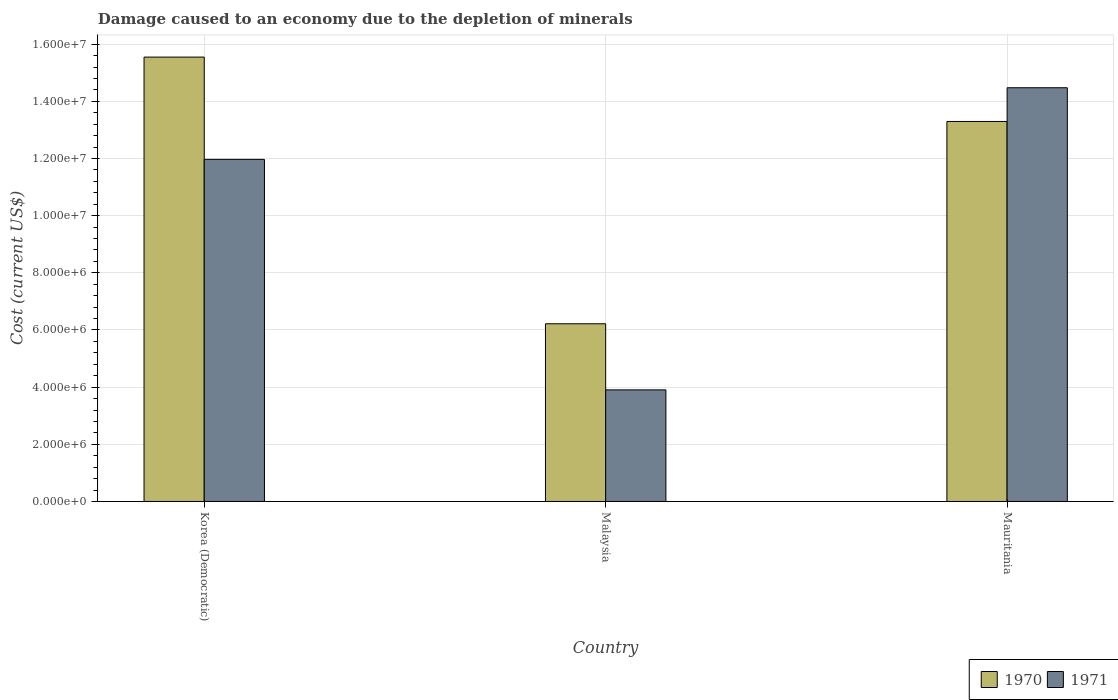How many different coloured bars are there?
Provide a succinct answer. 2. Are the number of bars per tick equal to the number of legend labels?
Provide a succinct answer. Yes. How many bars are there on the 3rd tick from the right?
Keep it short and to the point. 2. What is the label of the 3rd group of bars from the left?
Ensure brevity in your answer.  Mauritania. In how many cases, is the number of bars for a given country not equal to the number of legend labels?
Provide a succinct answer. 0. What is the cost of damage caused due to the depletion of minerals in 1971 in Malaysia?
Offer a very short reply. 3.90e+06. Across all countries, what is the maximum cost of damage caused due to the depletion of minerals in 1970?
Give a very brief answer. 1.55e+07. Across all countries, what is the minimum cost of damage caused due to the depletion of minerals in 1970?
Give a very brief answer. 6.22e+06. In which country was the cost of damage caused due to the depletion of minerals in 1970 maximum?
Ensure brevity in your answer.  Korea (Democratic). In which country was the cost of damage caused due to the depletion of minerals in 1970 minimum?
Give a very brief answer. Malaysia. What is the total cost of damage caused due to the depletion of minerals in 1970 in the graph?
Provide a succinct answer. 3.51e+07. What is the difference between the cost of damage caused due to the depletion of minerals in 1970 in Malaysia and that in Mauritania?
Offer a terse response. -7.08e+06. What is the difference between the cost of damage caused due to the depletion of minerals in 1970 in Mauritania and the cost of damage caused due to the depletion of minerals in 1971 in Malaysia?
Offer a very short reply. 9.39e+06. What is the average cost of damage caused due to the depletion of minerals in 1970 per country?
Keep it short and to the point. 1.17e+07. What is the difference between the cost of damage caused due to the depletion of minerals of/in 1970 and cost of damage caused due to the depletion of minerals of/in 1971 in Malaysia?
Offer a terse response. 2.31e+06. In how many countries, is the cost of damage caused due to the depletion of minerals in 1971 greater than 14800000 US$?
Ensure brevity in your answer.  0. What is the ratio of the cost of damage caused due to the depletion of minerals in 1970 in Korea (Democratic) to that in Malaysia?
Your answer should be very brief. 2.5. Is the cost of damage caused due to the depletion of minerals in 1971 in Korea (Democratic) less than that in Malaysia?
Make the answer very short. No. Is the difference between the cost of damage caused due to the depletion of minerals in 1970 in Korea (Democratic) and Malaysia greater than the difference between the cost of damage caused due to the depletion of minerals in 1971 in Korea (Democratic) and Malaysia?
Your response must be concise. Yes. What is the difference between the highest and the second highest cost of damage caused due to the depletion of minerals in 1970?
Provide a succinct answer. 7.08e+06. What is the difference between the highest and the lowest cost of damage caused due to the depletion of minerals in 1971?
Provide a succinct answer. 1.06e+07. Is the sum of the cost of damage caused due to the depletion of minerals in 1970 in Malaysia and Mauritania greater than the maximum cost of damage caused due to the depletion of minerals in 1971 across all countries?
Give a very brief answer. Yes. Are all the bars in the graph horizontal?
Provide a succinct answer. No. How many countries are there in the graph?
Your answer should be very brief. 3. What is the difference between two consecutive major ticks on the Y-axis?
Your answer should be compact. 2.00e+06. Does the graph contain any zero values?
Your answer should be very brief. No. Does the graph contain grids?
Offer a very short reply. Yes. Where does the legend appear in the graph?
Provide a succinct answer. Bottom right. How many legend labels are there?
Offer a terse response. 2. How are the legend labels stacked?
Keep it short and to the point. Horizontal. What is the title of the graph?
Give a very brief answer. Damage caused to an economy due to the depletion of minerals. Does "1991" appear as one of the legend labels in the graph?
Make the answer very short. No. What is the label or title of the X-axis?
Keep it short and to the point. Country. What is the label or title of the Y-axis?
Make the answer very short. Cost (current US$). What is the Cost (current US$) of 1970 in Korea (Democratic)?
Provide a short and direct response. 1.55e+07. What is the Cost (current US$) in 1971 in Korea (Democratic)?
Give a very brief answer. 1.20e+07. What is the Cost (current US$) in 1970 in Malaysia?
Provide a short and direct response. 6.22e+06. What is the Cost (current US$) in 1971 in Malaysia?
Your answer should be very brief. 3.90e+06. What is the Cost (current US$) in 1970 in Mauritania?
Offer a very short reply. 1.33e+07. What is the Cost (current US$) of 1971 in Mauritania?
Make the answer very short. 1.45e+07. Across all countries, what is the maximum Cost (current US$) in 1970?
Provide a succinct answer. 1.55e+07. Across all countries, what is the maximum Cost (current US$) in 1971?
Provide a succinct answer. 1.45e+07. Across all countries, what is the minimum Cost (current US$) in 1970?
Your answer should be compact. 6.22e+06. Across all countries, what is the minimum Cost (current US$) in 1971?
Your response must be concise. 3.90e+06. What is the total Cost (current US$) of 1970 in the graph?
Offer a very short reply. 3.51e+07. What is the total Cost (current US$) of 1971 in the graph?
Your answer should be compact. 3.03e+07. What is the difference between the Cost (current US$) in 1970 in Korea (Democratic) and that in Malaysia?
Give a very brief answer. 9.33e+06. What is the difference between the Cost (current US$) of 1971 in Korea (Democratic) and that in Malaysia?
Provide a short and direct response. 8.06e+06. What is the difference between the Cost (current US$) of 1970 in Korea (Democratic) and that in Mauritania?
Offer a terse response. 2.25e+06. What is the difference between the Cost (current US$) of 1971 in Korea (Democratic) and that in Mauritania?
Your answer should be very brief. -2.51e+06. What is the difference between the Cost (current US$) of 1970 in Malaysia and that in Mauritania?
Offer a terse response. -7.08e+06. What is the difference between the Cost (current US$) of 1971 in Malaysia and that in Mauritania?
Your answer should be very brief. -1.06e+07. What is the difference between the Cost (current US$) in 1970 in Korea (Democratic) and the Cost (current US$) in 1971 in Malaysia?
Keep it short and to the point. 1.16e+07. What is the difference between the Cost (current US$) in 1970 in Korea (Democratic) and the Cost (current US$) in 1971 in Mauritania?
Ensure brevity in your answer.  1.07e+06. What is the difference between the Cost (current US$) in 1970 in Malaysia and the Cost (current US$) in 1971 in Mauritania?
Make the answer very short. -8.26e+06. What is the average Cost (current US$) in 1970 per country?
Provide a succinct answer. 1.17e+07. What is the average Cost (current US$) in 1971 per country?
Ensure brevity in your answer.  1.01e+07. What is the difference between the Cost (current US$) in 1970 and Cost (current US$) in 1971 in Korea (Democratic)?
Offer a very short reply. 3.58e+06. What is the difference between the Cost (current US$) of 1970 and Cost (current US$) of 1971 in Malaysia?
Provide a short and direct response. 2.31e+06. What is the difference between the Cost (current US$) in 1970 and Cost (current US$) in 1971 in Mauritania?
Offer a very short reply. -1.18e+06. What is the ratio of the Cost (current US$) in 1970 in Korea (Democratic) to that in Malaysia?
Give a very brief answer. 2.5. What is the ratio of the Cost (current US$) in 1971 in Korea (Democratic) to that in Malaysia?
Ensure brevity in your answer.  3.07. What is the ratio of the Cost (current US$) of 1970 in Korea (Democratic) to that in Mauritania?
Make the answer very short. 1.17. What is the ratio of the Cost (current US$) in 1971 in Korea (Democratic) to that in Mauritania?
Provide a short and direct response. 0.83. What is the ratio of the Cost (current US$) of 1970 in Malaysia to that in Mauritania?
Provide a succinct answer. 0.47. What is the ratio of the Cost (current US$) in 1971 in Malaysia to that in Mauritania?
Provide a succinct answer. 0.27. What is the difference between the highest and the second highest Cost (current US$) of 1970?
Offer a terse response. 2.25e+06. What is the difference between the highest and the second highest Cost (current US$) in 1971?
Your response must be concise. 2.51e+06. What is the difference between the highest and the lowest Cost (current US$) in 1970?
Give a very brief answer. 9.33e+06. What is the difference between the highest and the lowest Cost (current US$) in 1971?
Provide a succinct answer. 1.06e+07. 